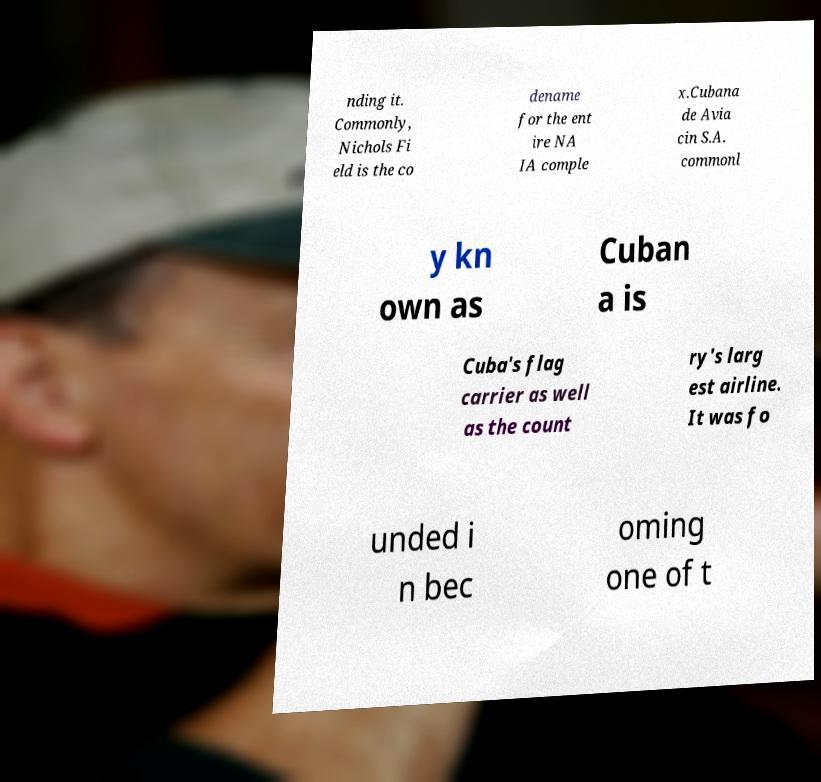Please read and relay the text visible in this image. What does it say? nding it. Commonly, Nichols Fi eld is the co dename for the ent ire NA IA comple x.Cubana de Avia cin S.A. commonl y kn own as Cuban a is Cuba's flag carrier as well as the count ry's larg est airline. It was fo unded i n bec oming one of t 